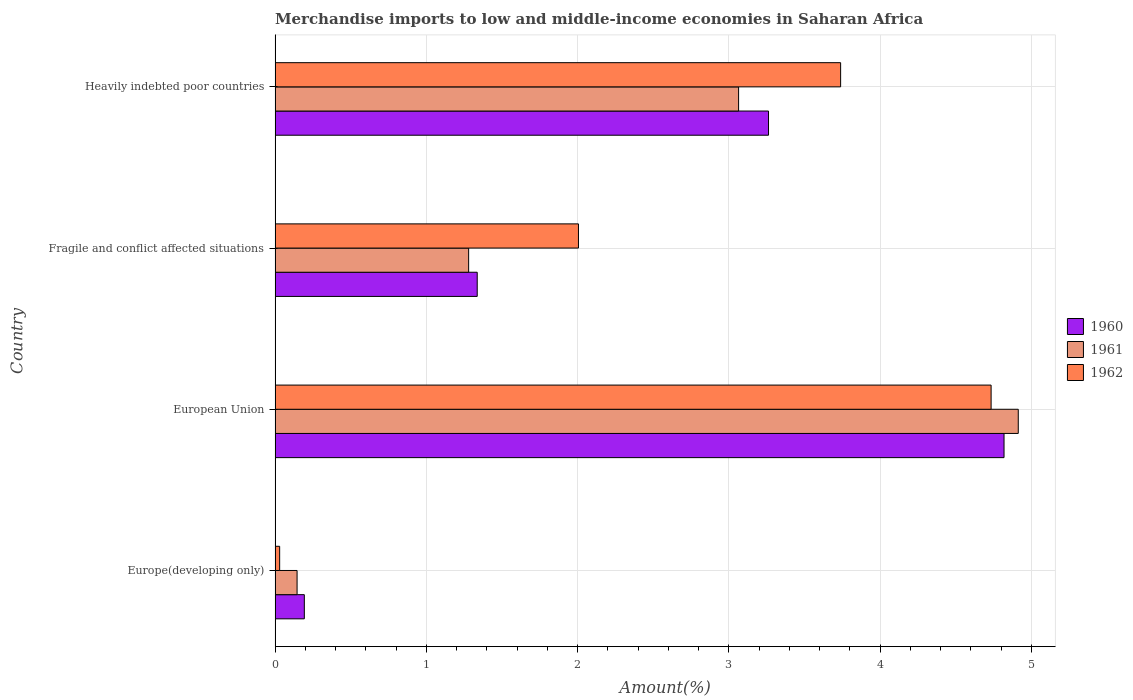How many different coloured bars are there?
Your answer should be compact. 3. How many groups of bars are there?
Offer a very short reply. 4. How many bars are there on the 4th tick from the top?
Offer a very short reply. 3. How many bars are there on the 3rd tick from the bottom?
Keep it short and to the point. 3. What is the label of the 1st group of bars from the top?
Offer a very short reply. Heavily indebted poor countries. In how many cases, is the number of bars for a given country not equal to the number of legend labels?
Your answer should be very brief. 0. What is the percentage of amount earned from merchandise imports in 1962 in European Union?
Your answer should be compact. 4.73. Across all countries, what is the maximum percentage of amount earned from merchandise imports in 1961?
Your response must be concise. 4.91. Across all countries, what is the minimum percentage of amount earned from merchandise imports in 1961?
Make the answer very short. 0.15. In which country was the percentage of amount earned from merchandise imports in 1962 minimum?
Offer a very short reply. Europe(developing only). What is the total percentage of amount earned from merchandise imports in 1962 in the graph?
Your answer should be very brief. 10.51. What is the difference between the percentage of amount earned from merchandise imports in 1960 in Europe(developing only) and that in Heavily indebted poor countries?
Give a very brief answer. -3.07. What is the difference between the percentage of amount earned from merchandise imports in 1962 in European Union and the percentage of amount earned from merchandise imports in 1961 in Europe(developing only)?
Your answer should be very brief. 4.59. What is the average percentage of amount earned from merchandise imports in 1962 per country?
Make the answer very short. 2.63. What is the difference between the percentage of amount earned from merchandise imports in 1961 and percentage of amount earned from merchandise imports in 1962 in Heavily indebted poor countries?
Make the answer very short. -0.67. In how many countries, is the percentage of amount earned from merchandise imports in 1962 greater than 3 %?
Provide a succinct answer. 2. What is the ratio of the percentage of amount earned from merchandise imports in 1961 in Europe(developing only) to that in Heavily indebted poor countries?
Your answer should be very brief. 0.05. Is the percentage of amount earned from merchandise imports in 1960 in European Union less than that in Heavily indebted poor countries?
Provide a succinct answer. No. Is the difference between the percentage of amount earned from merchandise imports in 1961 in Fragile and conflict affected situations and Heavily indebted poor countries greater than the difference between the percentage of amount earned from merchandise imports in 1962 in Fragile and conflict affected situations and Heavily indebted poor countries?
Ensure brevity in your answer.  No. What is the difference between the highest and the second highest percentage of amount earned from merchandise imports in 1961?
Offer a very short reply. 1.85. What is the difference between the highest and the lowest percentage of amount earned from merchandise imports in 1962?
Keep it short and to the point. 4.7. In how many countries, is the percentage of amount earned from merchandise imports in 1961 greater than the average percentage of amount earned from merchandise imports in 1961 taken over all countries?
Your answer should be compact. 2. Is the sum of the percentage of amount earned from merchandise imports in 1961 in Europe(developing only) and European Union greater than the maximum percentage of amount earned from merchandise imports in 1960 across all countries?
Offer a terse response. Yes. Is it the case that in every country, the sum of the percentage of amount earned from merchandise imports in 1960 and percentage of amount earned from merchandise imports in 1961 is greater than the percentage of amount earned from merchandise imports in 1962?
Provide a short and direct response. Yes. Are all the bars in the graph horizontal?
Keep it short and to the point. Yes. How many countries are there in the graph?
Provide a succinct answer. 4. Are the values on the major ticks of X-axis written in scientific E-notation?
Offer a terse response. No. Does the graph contain grids?
Provide a succinct answer. Yes. Where does the legend appear in the graph?
Offer a very short reply. Center right. How many legend labels are there?
Provide a short and direct response. 3. How are the legend labels stacked?
Your response must be concise. Vertical. What is the title of the graph?
Give a very brief answer. Merchandise imports to low and middle-income economies in Saharan Africa. Does "2015" appear as one of the legend labels in the graph?
Provide a succinct answer. No. What is the label or title of the X-axis?
Your answer should be compact. Amount(%). What is the Amount(%) of 1960 in Europe(developing only)?
Provide a succinct answer. 0.19. What is the Amount(%) in 1961 in Europe(developing only)?
Your answer should be compact. 0.15. What is the Amount(%) in 1962 in Europe(developing only)?
Ensure brevity in your answer.  0.03. What is the Amount(%) in 1960 in European Union?
Keep it short and to the point. 4.82. What is the Amount(%) in 1961 in European Union?
Keep it short and to the point. 4.91. What is the Amount(%) in 1962 in European Union?
Offer a very short reply. 4.73. What is the Amount(%) of 1960 in Fragile and conflict affected situations?
Provide a succinct answer. 1.34. What is the Amount(%) in 1961 in Fragile and conflict affected situations?
Give a very brief answer. 1.28. What is the Amount(%) in 1962 in Fragile and conflict affected situations?
Your response must be concise. 2.01. What is the Amount(%) of 1960 in Heavily indebted poor countries?
Provide a short and direct response. 3.26. What is the Amount(%) in 1961 in Heavily indebted poor countries?
Offer a very short reply. 3.06. What is the Amount(%) in 1962 in Heavily indebted poor countries?
Make the answer very short. 3.74. Across all countries, what is the maximum Amount(%) in 1960?
Make the answer very short. 4.82. Across all countries, what is the maximum Amount(%) in 1961?
Offer a terse response. 4.91. Across all countries, what is the maximum Amount(%) in 1962?
Ensure brevity in your answer.  4.73. Across all countries, what is the minimum Amount(%) of 1960?
Your answer should be compact. 0.19. Across all countries, what is the minimum Amount(%) of 1961?
Offer a terse response. 0.15. Across all countries, what is the minimum Amount(%) of 1962?
Make the answer very short. 0.03. What is the total Amount(%) of 1960 in the graph?
Give a very brief answer. 9.61. What is the total Amount(%) of 1961 in the graph?
Provide a short and direct response. 9.4. What is the total Amount(%) in 1962 in the graph?
Make the answer very short. 10.51. What is the difference between the Amount(%) in 1960 in Europe(developing only) and that in European Union?
Offer a very short reply. -4.63. What is the difference between the Amount(%) of 1961 in Europe(developing only) and that in European Union?
Your answer should be compact. -4.77. What is the difference between the Amount(%) in 1962 in Europe(developing only) and that in European Union?
Make the answer very short. -4.7. What is the difference between the Amount(%) of 1960 in Europe(developing only) and that in Fragile and conflict affected situations?
Your answer should be very brief. -1.14. What is the difference between the Amount(%) in 1961 in Europe(developing only) and that in Fragile and conflict affected situations?
Your answer should be very brief. -1.13. What is the difference between the Amount(%) of 1962 in Europe(developing only) and that in Fragile and conflict affected situations?
Offer a terse response. -1.98. What is the difference between the Amount(%) of 1960 in Europe(developing only) and that in Heavily indebted poor countries?
Offer a terse response. -3.07. What is the difference between the Amount(%) of 1961 in Europe(developing only) and that in Heavily indebted poor countries?
Your answer should be compact. -2.92. What is the difference between the Amount(%) in 1962 in Europe(developing only) and that in Heavily indebted poor countries?
Offer a very short reply. -3.71. What is the difference between the Amount(%) of 1960 in European Union and that in Fragile and conflict affected situations?
Give a very brief answer. 3.48. What is the difference between the Amount(%) of 1961 in European Union and that in Fragile and conflict affected situations?
Make the answer very short. 3.63. What is the difference between the Amount(%) in 1962 in European Union and that in Fragile and conflict affected situations?
Your response must be concise. 2.73. What is the difference between the Amount(%) of 1960 in European Union and that in Heavily indebted poor countries?
Keep it short and to the point. 1.56. What is the difference between the Amount(%) in 1961 in European Union and that in Heavily indebted poor countries?
Your answer should be very brief. 1.85. What is the difference between the Amount(%) of 1960 in Fragile and conflict affected situations and that in Heavily indebted poor countries?
Your response must be concise. -1.93. What is the difference between the Amount(%) in 1961 in Fragile and conflict affected situations and that in Heavily indebted poor countries?
Ensure brevity in your answer.  -1.78. What is the difference between the Amount(%) in 1962 in Fragile and conflict affected situations and that in Heavily indebted poor countries?
Offer a terse response. -1.73. What is the difference between the Amount(%) of 1960 in Europe(developing only) and the Amount(%) of 1961 in European Union?
Your response must be concise. -4.72. What is the difference between the Amount(%) in 1960 in Europe(developing only) and the Amount(%) in 1962 in European Union?
Your answer should be very brief. -4.54. What is the difference between the Amount(%) of 1961 in Europe(developing only) and the Amount(%) of 1962 in European Union?
Give a very brief answer. -4.59. What is the difference between the Amount(%) in 1960 in Europe(developing only) and the Amount(%) in 1961 in Fragile and conflict affected situations?
Provide a short and direct response. -1.09. What is the difference between the Amount(%) of 1960 in Europe(developing only) and the Amount(%) of 1962 in Fragile and conflict affected situations?
Your answer should be compact. -1.81. What is the difference between the Amount(%) in 1961 in Europe(developing only) and the Amount(%) in 1962 in Fragile and conflict affected situations?
Ensure brevity in your answer.  -1.86. What is the difference between the Amount(%) in 1960 in Europe(developing only) and the Amount(%) in 1961 in Heavily indebted poor countries?
Your response must be concise. -2.87. What is the difference between the Amount(%) of 1960 in Europe(developing only) and the Amount(%) of 1962 in Heavily indebted poor countries?
Provide a short and direct response. -3.55. What is the difference between the Amount(%) in 1961 in Europe(developing only) and the Amount(%) in 1962 in Heavily indebted poor countries?
Your response must be concise. -3.59. What is the difference between the Amount(%) in 1960 in European Union and the Amount(%) in 1961 in Fragile and conflict affected situations?
Your answer should be very brief. 3.54. What is the difference between the Amount(%) of 1960 in European Union and the Amount(%) of 1962 in Fragile and conflict affected situations?
Your answer should be compact. 2.81. What is the difference between the Amount(%) of 1961 in European Union and the Amount(%) of 1962 in Fragile and conflict affected situations?
Provide a short and direct response. 2.91. What is the difference between the Amount(%) in 1960 in European Union and the Amount(%) in 1961 in Heavily indebted poor countries?
Provide a short and direct response. 1.76. What is the difference between the Amount(%) of 1960 in European Union and the Amount(%) of 1962 in Heavily indebted poor countries?
Your answer should be very brief. 1.08. What is the difference between the Amount(%) in 1961 in European Union and the Amount(%) in 1962 in Heavily indebted poor countries?
Your answer should be very brief. 1.17. What is the difference between the Amount(%) of 1960 in Fragile and conflict affected situations and the Amount(%) of 1961 in Heavily indebted poor countries?
Keep it short and to the point. -1.73. What is the difference between the Amount(%) in 1960 in Fragile and conflict affected situations and the Amount(%) in 1962 in Heavily indebted poor countries?
Provide a succinct answer. -2.4. What is the difference between the Amount(%) of 1961 in Fragile and conflict affected situations and the Amount(%) of 1962 in Heavily indebted poor countries?
Ensure brevity in your answer.  -2.46. What is the average Amount(%) in 1960 per country?
Your response must be concise. 2.4. What is the average Amount(%) of 1961 per country?
Your response must be concise. 2.35. What is the average Amount(%) of 1962 per country?
Provide a succinct answer. 2.63. What is the difference between the Amount(%) of 1960 and Amount(%) of 1961 in Europe(developing only)?
Provide a succinct answer. 0.05. What is the difference between the Amount(%) in 1960 and Amount(%) in 1962 in Europe(developing only)?
Ensure brevity in your answer.  0.16. What is the difference between the Amount(%) of 1961 and Amount(%) of 1962 in Europe(developing only)?
Ensure brevity in your answer.  0.12. What is the difference between the Amount(%) of 1960 and Amount(%) of 1961 in European Union?
Your response must be concise. -0.09. What is the difference between the Amount(%) in 1960 and Amount(%) in 1962 in European Union?
Offer a terse response. 0.09. What is the difference between the Amount(%) in 1961 and Amount(%) in 1962 in European Union?
Offer a terse response. 0.18. What is the difference between the Amount(%) of 1960 and Amount(%) of 1961 in Fragile and conflict affected situations?
Your answer should be very brief. 0.06. What is the difference between the Amount(%) of 1960 and Amount(%) of 1962 in Fragile and conflict affected situations?
Your response must be concise. -0.67. What is the difference between the Amount(%) in 1961 and Amount(%) in 1962 in Fragile and conflict affected situations?
Your answer should be compact. -0.73. What is the difference between the Amount(%) of 1960 and Amount(%) of 1961 in Heavily indebted poor countries?
Keep it short and to the point. 0.2. What is the difference between the Amount(%) in 1960 and Amount(%) in 1962 in Heavily indebted poor countries?
Your answer should be compact. -0.48. What is the difference between the Amount(%) of 1961 and Amount(%) of 1962 in Heavily indebted poor countries?
Make the answer very short. -0.67. What is the ratio of the Amount(%) of 1960 in Europe(developing only) to that in European Union?
Give a very brief answer. 0.04. What is the ratio of the Amount(%) of 1961 in Europe(developing only) to that in European Union?
Your answer should be very brief. 0.03. What is the ratio of the Amount(%) in 1962 in Europe(developing only) to that in European Union?
Make the answer very short. 0.01. What is the ratio of the Amount(%) in 1960 in Europe(developing only) to that in Fragile and conflict affected situations?
Provide a short and direct response. 0.14. What is the ratio of the Amount(%) in 1961 in Europe(developing only) to that in Fragile and conflict affected situations?
Offer a very short reply. 0.11. What is the ratio of the Amount(%) in 1962 in Europe(developing only) to that in Fragile and conflict affected situations?
Offer a terse response. 0.02. What is the ratio of the Amount(%) of 1960 in Europe(developing only) to that in Heavily indebted poor countries?
Your answer should be compact. 0.06. What is the ratio of the Amount(%) of 1961 in Europe(developing only) to that in Heavily indebted poor countries?
Offer a terse response. 0.05. What is the ratio of the Amount(%) of 1962 in Europe(developing only) to that in Heavily indebted poor countries?
Your answer should be compact. 0.01. What is the ratio of the Amount(%) in 1960 in European Union to that in Fragile and conflict affected situations?
Keep it short and to the point. 3.61. What is the ratio of the Amount(%) of 1961 in European Union to that in Fragile and conflict affected situations?
Offer a very short reply. 3.84. What is the ratio of the Amount(%) of 1962 in European Union to that in Fragile and conflict affected situations?
Your response must be concise. 2.36. What is the ratio of the Amount(%) of 1960 in European Union to that in Heavily indebted poor countries?
Keep it short and to the point. 1.48. What is the ratio of the Amount(%) in 1961 in European Union to that in Heavily indebted poor countries?
Your answer should be compact. 1.6. What is the ratio of the Amount(%) of 1962 in European Union to that in Heavily indebted poor countries?
Ensure brevity in your answer.  1.27. What is the ratio of the Amount(%) in 1960 in Fragile and conflict affected situations to that in Heavily indebted poor countries?
Keep it short and to the point. 0.41. What is the ratio of the Amount(%) of 1961 in Fragile and conflict affected situations to that in Heavily indebted poor countries?
Make the answer very short. 0.42. What is the ratio of the Amount(%) in 1962 in Fragile and conflict affected situations to that in Heavily indebted poor countries?
Keep it short and to the point. 0.54. What is the difference between the highest and the second highest Amount(%) of 1960?
Provide a succinct answer. 1.56. What is the difference between the highest and the second highest Amount(%) in 1961?
Keep it short and to the point. 1.85. What is the difference between the highest and the lowest Amount(%) in 1960?
Ensure brevity in your answer.  4.63. What is the difference between the highest and the lowest Amount(%) of 1961?
Provide a short and direct response. 4.77. What is the difference between the highest and the lowest Amount(%) of 1962?
Offer a very short reply. 4.7. 